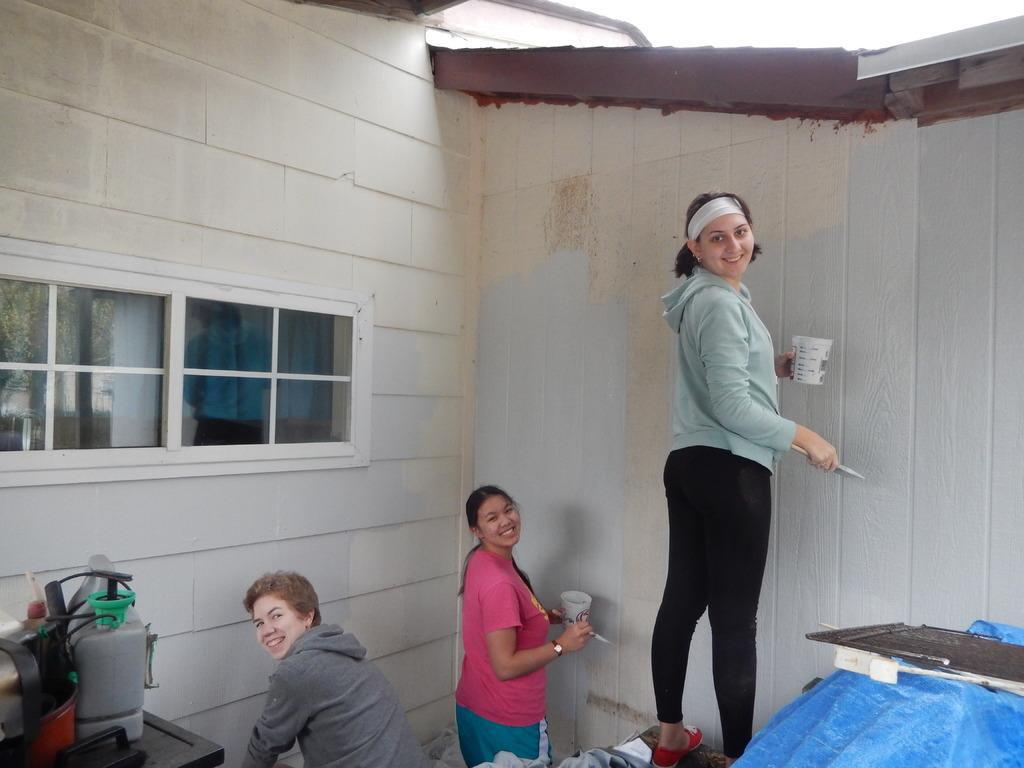How would you summarize this image in a sentence or two? In this image I can see three persons in the front and the right two of them are holding glasses and brushes. In the background I can see a building. On the left side of this image I can see windows and few other things. On the right bottom side I can see a blue colour thing. 